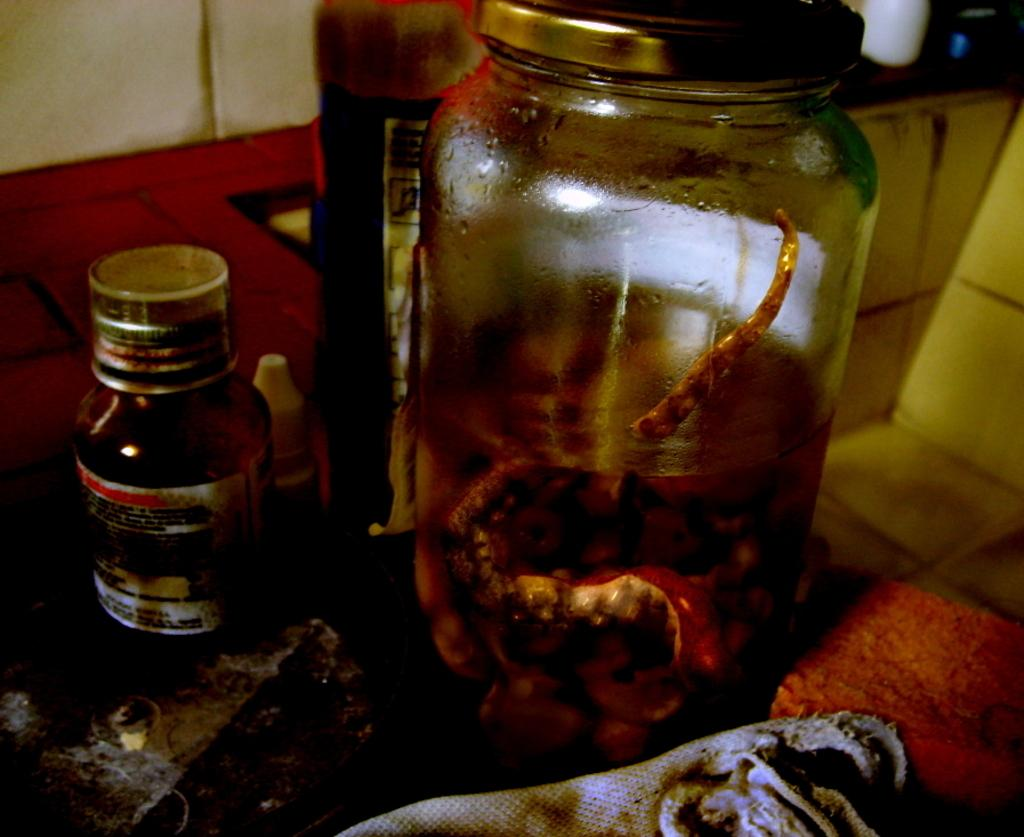What type of objects can be seen in the image? There are bottles in the image. Can you describe the arrangement of the objects in the image? There are other objects on a platform in the image. What type of nut is used in the invention depicted in the image? There is no invention or nut present in the image; it only features bottles and other objects on a platform. 